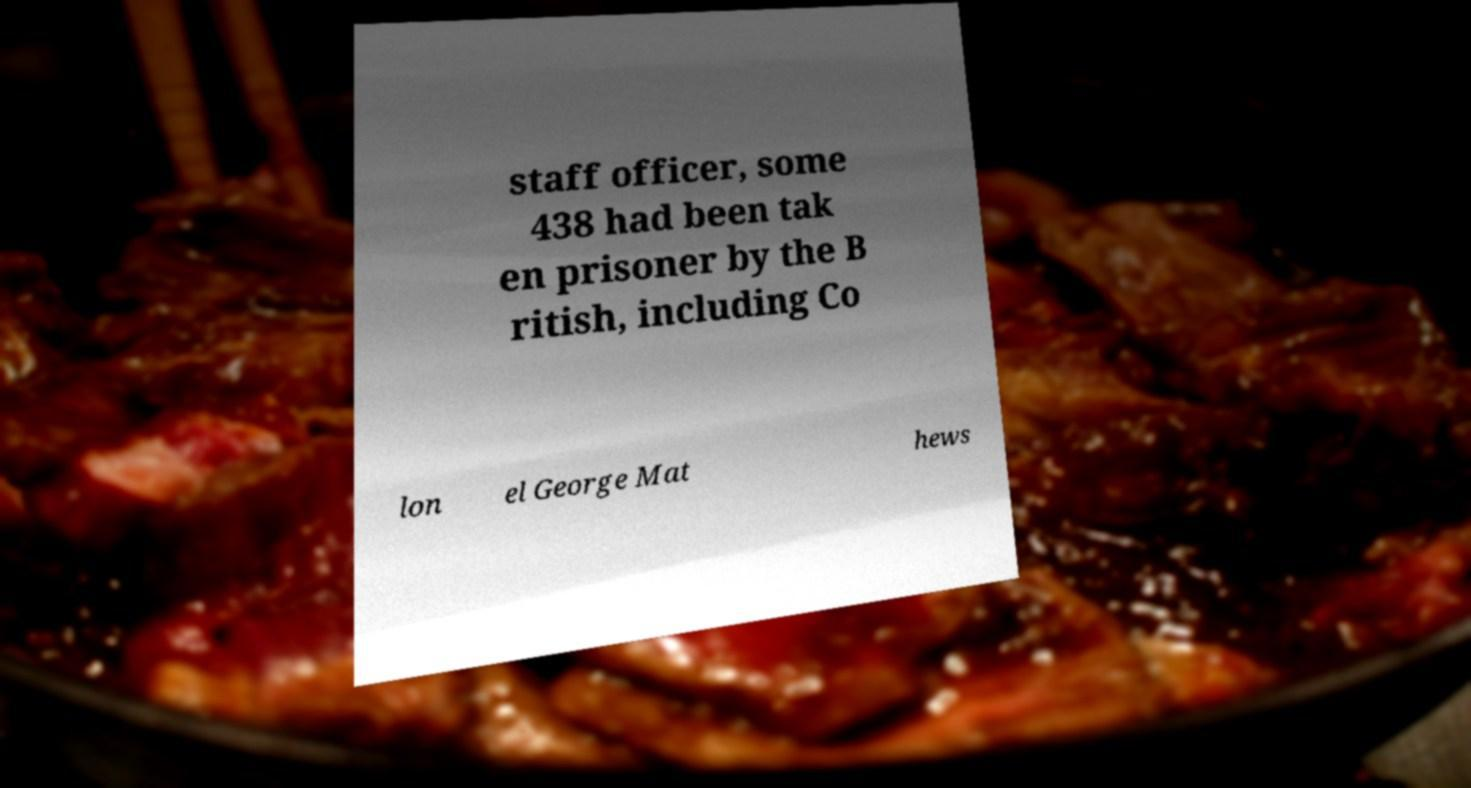Please identify and transcribe the text found in this image. staff officer, some 438 had been tak en prisoner by the B ritish, including Co lon el George Mat hews 